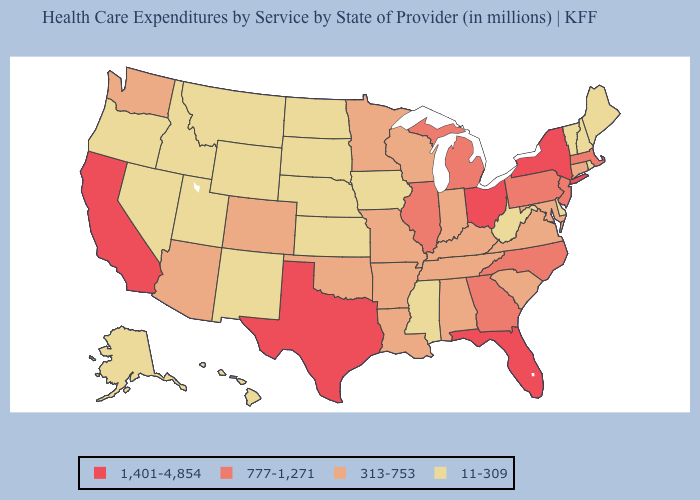Does New Jersey have the lowest value in the USA?
Quick response, please. No. What is the lowest value in the USA?
Quick response, please. 11-309. Name the states that have a value in the range 313-753?
Short answer required. Alabama, Arizona, Arkansas, Colorado, Connecticut, Indiana, Kentucky, Louisiana, Maryland, Minnesota, Missouri, Oklahoma, South Carolina, Tennessee, Virginia, Washington, Wisconsin. Which states hav the highest value in the Northeast?
Keep it brief. New York. Does New Hampshire have a higher value than Maine?
Be succinct. No. What is the value of South Carolina?
Be succinct. 313-753. Does Maryland have the lowest value in the South?
Quick response, please. No. Does Vermont have the highest value in the USA?
Short answer required. No. What is the value of California?
Give a very brief answer. 1,401-4,854. Does the first symbol in the legend represent the smallest category?
Be succinct. No. What is the value of Kansas?
Be succinct. 11-309. What is the lowest value in the USA?
Write a very short answer. 11-309. What is the value of Florida?
Be succinct. 1,401-4,854. What is the lowest value in the USA?
Be succinct. 11-309. What is the value of Wyoming?
Quick response, please. 11-309. 